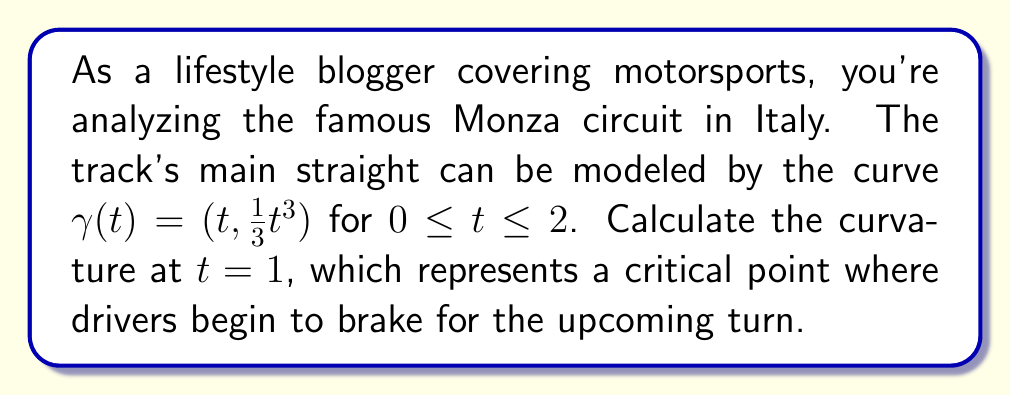Could you help me with this problem? To find the curvature of the race track at $t = 1$, we'll follow these steps:

1) The curvature $\kappa$ of a parametric curve $\gamma(t) = (x(t), y(t))$ is given by:

   $$\kappa = \frac{|x'y'' - y'x''|}{(x'^2 + y'^2)^{3/2}}$$

2) First, let's calculate the first and second derivatives:
   
   $x(t) = t$, so $x'(t) = 1$ and $x''(t) = 0$
   $y(t) = \frac{1}{3}t^3$, so $y'(t) = t^2$ and $y''(t) = 2t$

3) Now, let's substitute these into our curvature formula:

   $$\kappa = \frac{|1 \cdot 2t - t^2 \cdot 0|}{(1^2 + t^4)^{3/2}}$$

4) Simplify:

   $$\kappa = \frac{2t}{(1 + t^4)^{3/2}}$$

5) We want to find the curvature at $t = 1$, so let's substitute $t = 1$:

   $$\kappa = \frac{2(1)}{(1 + 1^4)^{3/2}} = \frac{2}{2^{3/2}} = \frac{2}{2\sqrt{2}} = \frac{1}{\sqrt{2}}$$

Therefore, the curvature at $t = 1$ is $\frac{1}{\sqrt{2}}$.
Answer: $\frac{1}{\sqrt{2}}$ 